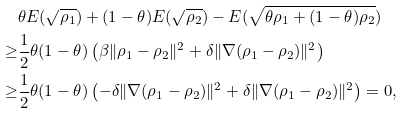<formula> <loc_0><loc_0><loc_500><loc_500>& \theta E ( \sqrt { \rho _ { 1 } } ) + ( 1 - \theta ) E ( \sqrt { \rho _ { 2 } } ) - E ( \sqrt { \theta \rho _ { 1 } + ( 1 - \theta ) \rho _ { 2 } } ) \\ \geq & \frac { 1 } { 2 } \theta ( 1 - \theta ) \left ( \beta \| \rho _ { 1 } - \rho _ { 2 } \| ^ { 2 } + \delta \| \nabla ( \rho _ { 1 } - \rho _ { 2 } ) \| ^ { 2 } \right ) \\ \geq & \frac { 1 } { 2 } \theta ( 1 - \theta ) \left ( - \delta \| \nabla ( \rho _ { 1 } - \rho _ { 2 } ) \| ^ { 2 } + \delta \| \nabla ( \rho _ { 1 } - \rho _ { 2 } ) \| ^ { 2 } \right ) = 0 ,</formula> 